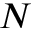Convert formula to latex. <formula><loc_0><loc_0><loc_500><loc_500>N</formula> 